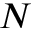Convert formula to latex. <formula><loc_0><loc_0><loc_500><loc_500>N</formula> 